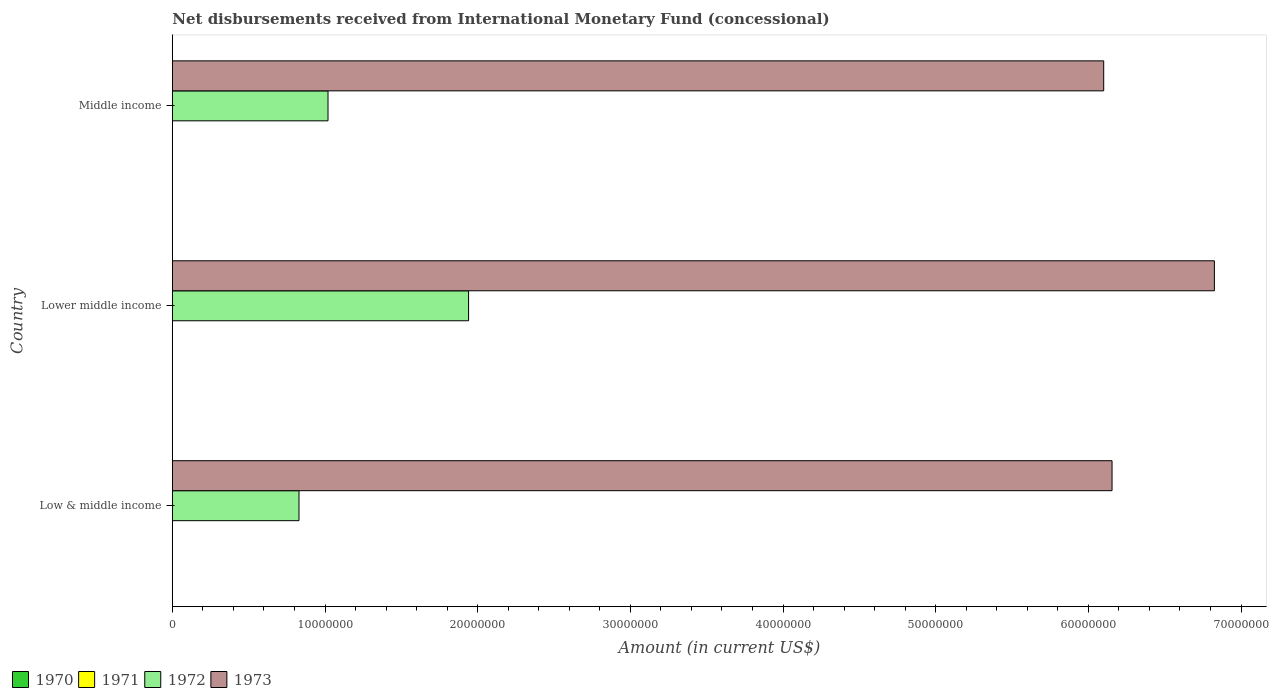How many different coloured bars are there?
Offer a very short reply. 2. How many groups of bars are there?
Provide a succinct answer. 3. Are the number of bars per tick equal to the number of legend labels?
Provide a succinct answer. No. Are the number of bars on each tick of the Y-axis equal?
Your answer should be very brief. Yes. How many bars are there on the 2nd tick from the top?
Provide a short and direct response. 2. How many bars are there on the 1st tick from the bottom?
Make the answer very short. 2. What is the label of the 1st group of bars from the top?
Your answer should be compact. Middle income. In how many cases, is the number of bars for a given country not equal to the number of legend labels?
Ensure brevity in your answer.  3. What is the amount of disbursements received from International Monetary Fund in 1970 in Middle income?
Your answer should be compact. 0. Across all countries, what is the maximum amount of disbursements received from International Monetary Fund in 1972?
Provide a short and direct response. 1.94e+07. Across all countries, what is the minimum amount of disbursements received from International Monetary Fund in 1972?
Your answer should be very brief. 8.30e+06. In which country was the amount of disbursements received from International Monetary Fund in 1972 maximum?
Your answer should be compact. Lower middle income. What is the difference between the amount of disbursements received from International Monetary Fund in 1972 in Lower middle income and that in Middle income?
Your answer should be very brief. 9.21e+06. What is the difference between the amount of disbursements received from International Monetary Fund in 1972 in Middle income and the amount of disbursements received from International Monetary Fund in 1971 in Low & middle income?
Your answer should be compact. 1.02e+07. What is the average amount of disbursements received from International Monetary Fund in 1972 per country?
Your answer should be compact. 1.26e+07. What is the difference between the amount of disbursements received from International Monetary Fund in 1972 and amount of disbursements received from International Monetary Fund in 1973 in Lower middle income?
Your answer should be compact. -4.89e+07. What is the ratio of the amount of disbursements received from International Monetary Fund in 1972 in Low & middle income to that in Lower middle income?
Provide a succinct answer. 0.43. Is the amount of disbursements received from International Monetary Fund in 1973 in Lower middle income less than that in Middle income?
Your response must be concise. No. Is the difference between the amount of disbursements received from International Monetary Fund in 1972 in Low & middle income and Middle income greater than the difference between the amount of disbursements received from International Monetary Fund in 1973 in Low & middle income and Middle income?
Offer a terse response. No. What is the difference between the highest and the second highest amount of disbursements received from International Monetary Fund in 1972?
Ensure brevity in your answer.  9.21e+06. What is the difference between the highest and the lowest amount of disbursements received from International Monetary Fund in 1973?
Offer a very short reply. 7.25e+06. Is the sum of the amount of disbursements received from International Monetary Fund in 1973 in Lower middle income and Middle income greater than the maximum amount of disbursements received from International Monetary Fund in 1972 across all countries?
Keep it short and to the point. Yes. How many countries are there in the graph?
Your answer should be compact. 3. Does the graph contain any zero values?
Ensure brevity in your answer.  Yes. Where does the legend appear in the graph?
Provide a succinct answer. Bottom left. What is the title of the graph?
Keep it short and to the point. Net disbursements received from International Monetary Fund (concessional). Does "1994" appear as one of the legend labels in the graph?
Ensure brevity in your answer.  No. What is the label or title of the X-axis?
Ensure brevity in your answer.  Amount (in current US$). What is the Amount (in current US$) of 1971 in Low & middle income?
Your answer should be compact. 0. What is the Amount (in current US$) in 1972 in Low & middle income?
Offer a terse response. 8.30e+06. What is the Amount (in current US$) of 1973 in Low & middle income?
Your answer should be very brief. 6.16e+07. What is the Amount (in current US$) of 1971 in Lower middle income?
Keep it short and to the point. 0. What is the Amount (in current US$) in 1972 in Lower middle income?
Provide a succinct answer. 1.94e+07. What is the Amount (in current US$) in 1973 in Lower middle income?
Your answer should be compact. 6.83e+07. What is the Amount (in current US$) of 1971 in Middle income?
Make the answer very short. 0. What is the Amount (in current US$) in 1972 in Middle income?
Ensure brevity in your answer.  1.02e+07. What is the Amount (in current US$) of 1973 in Middle income?
Your response must be concise. 6.10e+07. Across all countries, what is the maximum Amount (in current US$) of 1972?
Provide a succinct answer. 1.94e+07. Across all countries, what is the maximum Amount (in current US$) of 1973?
Provide a short and direct response. 6.83e+07. Across all countries, what is the minimum Amount (in current US$) of 1972?
Your answer should be very brief. 8.30e+06. Across all countries, what is the minimum Amount (in current US$) of 1973?
Your answer should be compact. 6.10e+07. What is the total Amount (in current US$) of 1970 in the graph?
Give a very brief answer. 0. What is the total Amount (in current US$) of 1972 in the graph?
Offer a terse response. 3.79e+07. What is the total Amount (in current US$) of 1973 in the graph?
Make the answer very short. 1.91e+08. What is the difference between the Amount (in current US$) in 1972 in Low & middle income and that in Lower middle income?
Ensure brevity in your answer.  -1.11e+07. What is the difference between the Amount (in current US$) in 1973 in Low & middle income and that in Lower middle income?
Your answer should be very brief. -6.70e+06. What is the difference between the Amount (in current US$) of 1972 in Low & middle income and that in Middle income?
Make the answer very short. -1.90e+06. What is the difference between the Amount (in current US$) in 1973 in Low & middle income and that in Middle income?
Make the answer very short. 5.46e+05. What is the difference between the Amount (in current US$) of 1972 in Lower middle income and that in Middle income?
Make the answer very short. 9.21e+06. What is the difference between the Amount (in current US$) of 1973 in Lower middle income and that in Middle income?
Keep it short and to the point. 7.25e+06. What is the difference between the Amount (in current US$) in 1972 in Low & middle income and the Amount (in current US$) in 1973 in Lower middle income?
Offer a terse response. -6.00e+07. What is the difference between the Amount (in current US$) in 1972 in Low & middle income and the Amount (in current US$) in 1973 in Middle income?
Your answer should be very brief. -5.27e+07. What is the difference between the Amount (in current US$) of 1972 in Lower middle income and the Amount (in current US$) of 1973 in Middle income?
Provide a short and direct response. -4.16e+07. What is the average Amount (in current US$) of 1971 per country?
Offer a very short reply. 0. What is the average Amount (in current US$) in 1972 per country?
Offer a very short reply. 1.26e+07. What is the average Amount (in current US$) of 1973 per country?
Offer a terse response. 6.36e+07. What is the difference between the Amount (in current US$) in 1972 and Amount (in current US$) in 1973 in Low & middle income?
Make the answer very short. -5.33e+07. What is the difference between the Amount (in current US$) in 1972 and Amount (in current US$) in 1973 in Lower middle income?
Your response must be concise. -4.89e+07. What is the difference between the Amount (in current US$) of 1972 and Amount (in current US$) of 1973 in Middle income?
Your answer should be compact. -5.08e+07. What is the ratio of the Amount (in current US$) in 1972 in Low & middle income to that in Lower middle income?
Offer a terse response. 0.43. What is the ratio of the Amount (in current US$) of 1973 in Low & middle income to that in Lower middle income?
Your answer should be very brief. 0.9. What is the ratio of the Amount (in current US$) in 1972 in Low & middle income to that in Middle income?
Offer a very short reply. 0.81. What is the ratio of the Amount (in current US$) of 1972 in Lower middle income to that in Middle income?
Your answer should be compact. 1.9. What is the ratio of the Amount (in current US$) of 1973 in Lower middle income to that in Middle income?
Give a very brief answer. 1.12. What is the difference between the highest and the second highest Amount (in current US$) in 1972?
Keep it short and to the point. 9.21e+06. What is the difference between the highest and the second highest Amount (in current US$) in 1973?
Your response must be concise. 6.70e+06. What is the difference between the highest and the lowest Amount (in current US$) of 1972?
Make the answer very short. 1.11e+07. What is the difference between the highest and the lowest Amount (in current US$) in 1973?
Your answer should be compact. 7.25e+06. 